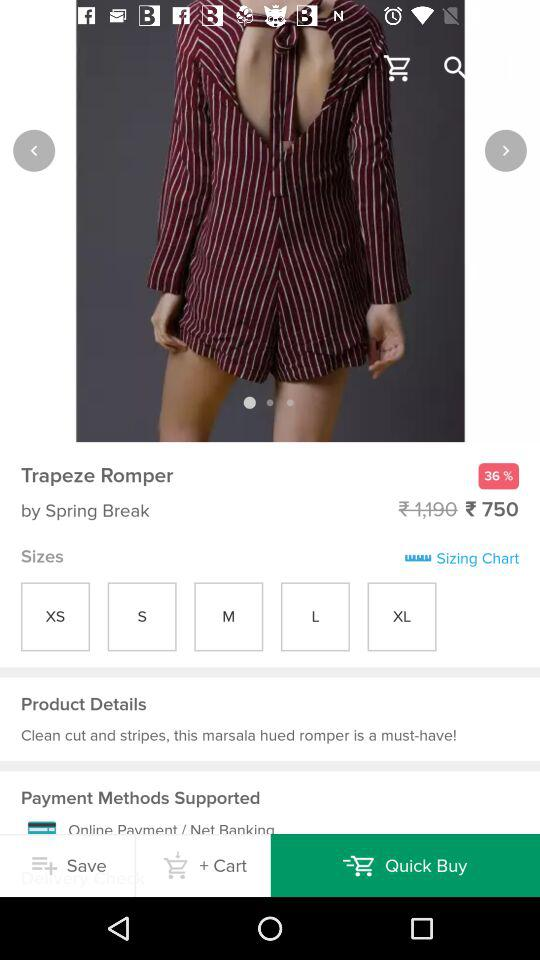What is the actual price? The actual price is ₹ 1,190. 